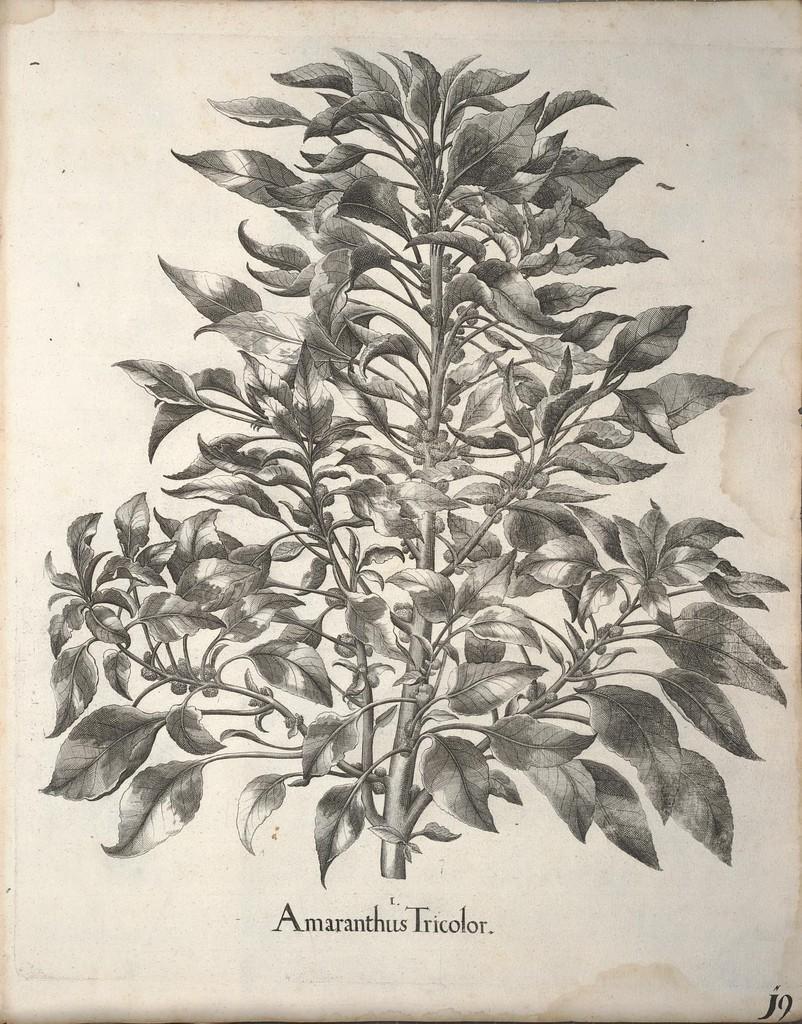Can you describe this image briefly? In this picture we can see a plant and some text on paper. 